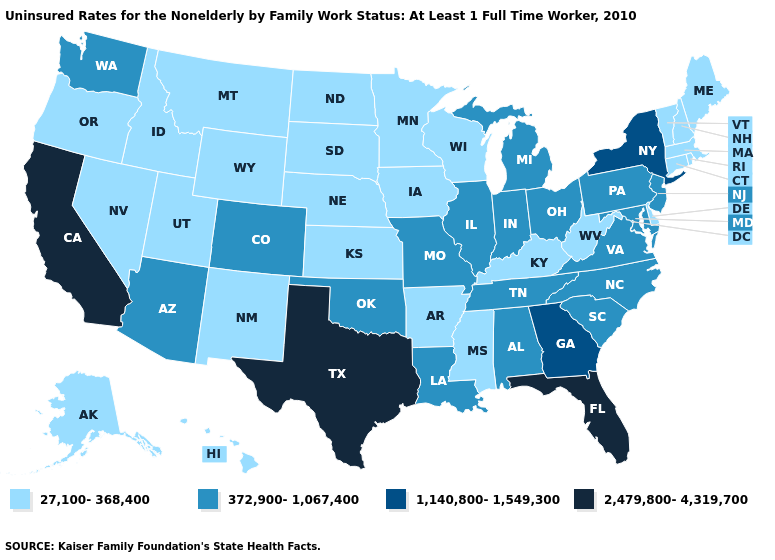What is the highest value in states that border South Dakota?
Concise answer only. 27,100-368,400. Does Texas have the highest value in the USA?
Write a very short answer. Yes. Which states have the lowest value in the South?
Write a very short answer. Arkansas, Delaware, Kentucky, Mississippi, West Virginia. What is the value of Michigan?
Quick response, please. 372,900-1,067,400. Does Idaho have the highest value in the West?
Quick response, please. No. Which states have the lowest value in the USA?
Quick response, please. Alaska, Arkansas, Connecticut, Delaware, Hawaii, Idaho, Iowa, Kansas, Kentucky, Maine, Massachusetts, Minnesota, Mississippi, Montana, Nebraska, Nevada, New Hampshire, New Mexico, North Dakota, Oregon, Rhode Island, South Dakota, Utah, Vermont, West Virginia, Wisconsin, Wyoming. Among the states that border Illinois , which have the highest value?
Answer briefly. Indiana, Missouri. Does the first symbol in the legend represent the smallest category?
Keep it brief. Yes. Which states hav the highest value in the Northeast?
Quick response, please. New York. Does Mississippi have a lower value than Texas?
Give a very brief answer. Yes. Name the states that have a value in the range 1,140,800-1,549,300?
Keep it brief. Georgia, New York. Does Michigan have the highest value in the USA?
Short answer required. No. What is the lowest value in states that border Maine?
Short answer required. 27,100-368,400. Is the legend a continuous bar?
Concise answer only. No. 